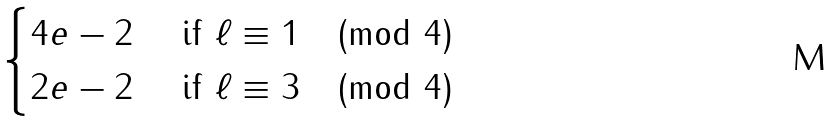Convert formula to latex. <formula><loc_0><loc_0><loc_500><loc_500>\begin{cases} 4 e - 2 & \text { if } \ell \equiv 1 \pmod { 4 } \\ 2 e - 2 & \text { if } \ell \equiv 3 \pmod { 4 } \\ \end{cases}</formula> 